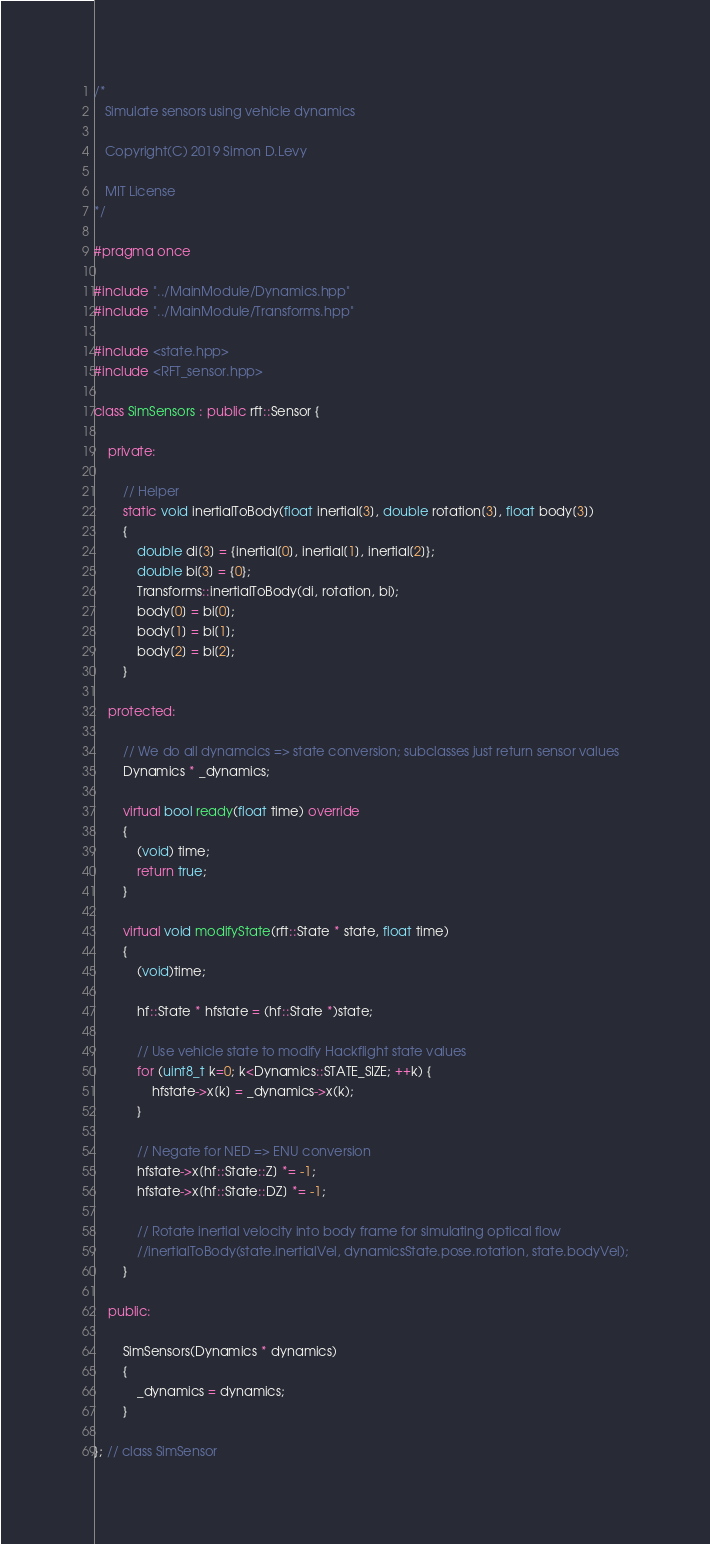<code> <loc_0><loc_0><loc_500><loc_500><_C++_>/*
   Simulate sensors using vehicle dynamics

   Copyright(C) 2019 Simon D.Levy

   MIT License
*/

#pragma once

#include "../MainModule/Dynamics.hpp"
#include "../MainModule/Transforms.hpp"

#include <state.hpp>
#include <RFT_sensor.hpp>

class SimSensors : public rft::Sensor {

    private:

        // Helper
        static void inertialToBody(float inertial[3], double rotation[3], float body[3])
        {
            double di[3] = {inertial[0], inertial[1], inertial[2]};
            double bi[3] = {0};
            Transforms::inertialToBody(di, rotation, bi);
            body[0] = bi[0];
            body[1] = bi[1];
            body[2] = bi[2];
        }

    protected:

        // We do all dynamcics => state conversion; subclasses just return sensor values
        Dynamics * _dynamics;

        virtual bool ready(float time) override
        {
            (void) time;
            return true;
        }

        virtual void modifyState(rft::State * state, float time)
        {
            (void)time;

            hf::State * hfstate = (hf::State *)state;

            // Use vehicle state to modify Hackflight state values
            for (uint8_t k=0; k<Dynamics::STATE_SIZE; ++k) {
                hfstate->x[k] = _dynamics->x(k);
            }

            // Negate for NED => ENU conversion
            hfstate->x[hf::State::Z] *= -1;
            hfstate->x[hf::State::DZ] *= -1;

            // Rotate inertial velocity into body frame for simulating optical flow
            //inertialToBody(state.inertialVel, dynamicsState.pose.rotation, state.bodyVel);
        }

    public:

        SimSensors(Dynamics * dynamics)
        {
            _dynamics = dynamics;
        }

}; // class SimSensor
</code> 